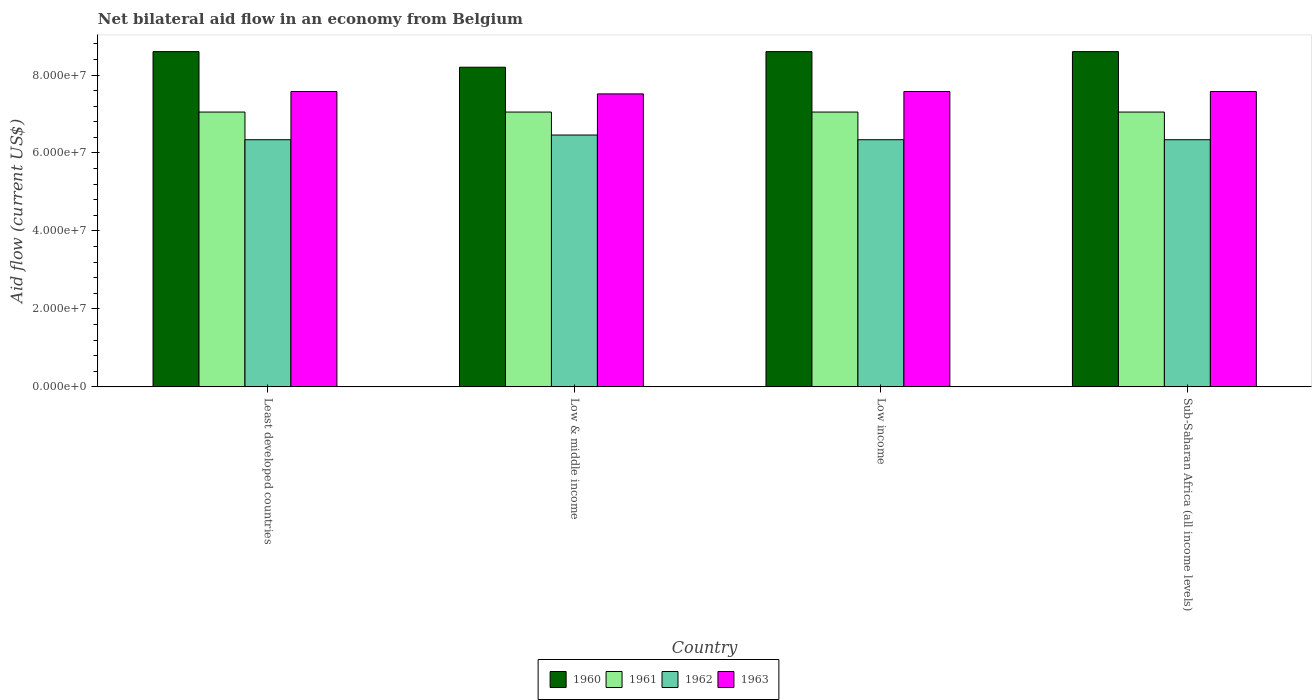How many different coloured bars are there?
Offer a terse response. 4. How many groups of bars are there?
Give a very brief answer. 4. Are the number of bars per tick equal to the number of legend labels?
Your answer should be compact. Yes. Are the number of bars on each tick of the X-axis equal?
Your answer should be very brief. Yes. How many bars are there on the 1st tick from the left?
Your answer should be very brief. 4. How many bars are there on the 4th tick from the right?
Your response must be concise. 4. What is the label of the 2nd group of bars from the left?
Provide a short and direct response. Low & middle income. What is the net bilateral aid flow in 1961 in Low income?
Ensure brevity in your answer.  7.05e+07. Across all countries, what is the maximum net bilateral aid flow in 1960?
Offer a terse response. 8.60e+07. Across all countries, what is the minimum net bilateral aid flow in 1961?
Offer a terse response. 7.05e+07. In which country was the net bilateral aid flow in 1960 minimum?
Provide a succinct answer. Low & middle income. What is the total net bilateral aid flow in 1960 in the graph?
Your response must be concise. 3.40e+08. What is the difference between the net bilateral aid flow in 1963 in Least developed countries and that in Sub-Saharan Africa (all income levels)?
Provide a succinct answer. 0. What is the difference between the net bilateral aid flow in 1961 in Low income and the net bilateral aid flow in 1960 in Least developed countries?
Make the answer very short. -1.55e+07. What is the average net bilateral aid flow in 1961 per country?
Provide a short and direct response. 7.05e+07. What is the difference between the net bilateral aid flow of/in 1961 and net bilateral aid flow of/in 1963 in Sub-Saharan Africa (all income levels)?
Provide a succinct answer. -5.27e+06. In how many countries, is the net bilateral aid flow in 1960 greater than 68000000 US$?
Give a very brief answer. 4. What is the ratio of the net bilateral aid flow in 1960 in Low & middle income to that in Low income?
Your response must be concise. 0.95. Is the net bilateral aid flow in 1960 in Least developed countries less than that in Low income?
Your response must be concise. No. What is the difference between the highest and the second highest net bilateral aid flow in 1962?
Ensure brevity in your answer.  1.21e+06. What is the difference between the highest and the lowest net bilateral aid flow in 1962?
Provide a succinct answer. 1.21e+06. Is the sum of the net bilateral aid flow in 1962 in Low income and Sub-Saharan Africa (all income levels) greater than the maximum net bilateral aid flow in 1961 across all countries?
Make the answer very short. Yes. Is it the case that in every country, the sum of the net bilateral aid flow in 1960 and net bilateral aid flow in 1962 is greater than the net bilateral aid flow in 1961?
Your answer should be compact. Yes. How many bars are there?
Give a very brief answer. 16. Are all the bars in the graph horizontal?
Your answer should be very brief. No. Where does the legend appear in the graph?
Ensure brevity in your answer.  Bottom center. How many legend labels are there?
Provide a short and direct response. 4. How are the legend labels stacked?
Provide a short and direct response. Horizontal. What is the title of the graph?
Keep it short and to the point. Net bilateral aid flow in an economy from Belgium. Does "2013" appear as one of the legend labels in the graph?
Your answer should be very brief. No. What is the Aid flow (current US$) of 1960 in Least developed countries?
Provide a short and direct response. 8.60e+07. What is the Aid flow (current US$) of 1961 in Least developed countries?
Your answer should be compact. 7.05e+07. What is the Aid flow (current US$) in 1962 in Least developed countries?
Keep it short and to the point. 6.34e+07. What is the Aid flow (current US$) of 1963 in Least developed countries?
Ensure brevity in your answer.  7.58e+07. What is the Aid flow (current US$) of 1960 in Low & middle income?
Give a very brief answer. 8.20e+07. What is the Aid flow (current US$) in 1961 in Low & middle income?
Keep it short and to the point. 7.05e+07. What is the Aid flow (current US$) in 1962 in Low & middle income?
Your answer should be compact. 6.46e+07. What is the Aid flow (current US$) in 1963 in Low & middle income?
Ensure brevity in your answer.  7.52e+07. What is the Aid flow (current US$) of 1960 in Low income?
Offer a terse response. 8.60e+07. What is the Aid flow (current US$) in 1961 in Low income?
Your answer should be very brief. 7.05e+07. What is the Aid flow (current US$) of 1962 in Low income?
Give a very brief answer. 6.34e+07. What is the Aid flow (current US$) of 1963 in Low income?
Your answer should be compact. 7.58e+07. What is the Aid flow (current US$) of 1960 in Sub-Saharan Africa (all income levels)?
Provide a short and direct response. 8.60e+07. What is the Aid flow (current US$) of 1961 in Sub-Saharan Africa (all income levels)?
Provide a succinct answer. 7.05e+07. What is the Aid flow (current US$) in 1962 in Sub-Saharan Africa (all income levels)?
Offer a very short reply. 6.34e+07. What is the Aid flow (current US$) in 1963 in Sub-Saharan Africa (all income levels)?
Give a very brief answer. 7.58e+07. Across all countries, what is the maximum Aid flow (current US$) in 1960?
Make the answer very short. 8.60e+07. Across all countries, what is the maximum Aid flow (current US$) in 1961?
Provide a short and direct response. 7.05e+07. Across all countries, what is the maximum Aid flow (current US$) in 1962?
Your response must be concise. 6.46e+07. Across all countries, what is the maximum Aid flow (current US$) in 1963?
Offer a very short reply. 7.58e+07. Across all countries, what is the minimum Aid flow (current US$) in 1960?
Keep it short and to the point. 8.20e+07. Across all countries, what is the minimum Aid flow (current US$) of 1961?
Keep it short and to the point. 7.05e+07. Across all countries, what is the minimum Aid flow (current US$) of 1962?
Offer a very short reply. 6.34e+07. Across all countries, what is the minimum Aid flow (current US$) in 1963?
Keep it short and to the point. 7.52e+07. What is the total Aid flow (current US$) in 1960 in the graph?
Ensure brevity in your answer.  3.40e+08. What is the total Aid flow (current US$) of 1961 in the graph?
Ensure brevity in your answer.  2.82e+08. What is the total Aid flow (current US$) in 1962 in the graph?
Keep it short and to the point. 2.55e+08. What is the total Aid flow (current US$) in 1963 in the graph?
Provide a succinct answer. 3.02e+08. What is the difference between the Aid flow (current US$) in 1960 in Least developed countries and that in Low & middle income?
Provide a short and direct response. 4.00e+06. What is the difference between the Aid flow (current US$) of 1961 in Least developed countries and that in Low & middle income?
Give a very brief answer. 0. What is the difference between the Aid flow (current US$) of 1962 in Least developed countries and that in Low & middle income?
Make the answer very short. -1.21e+06. What is the difference between the Aid flow (current US$) of 1963 in Least developed countries and that in Low & middle income?
Make the answer very short. 6.10e+05. What is the difference between the Aid flow (current US$) of 1960 in Least developed countries and that in Low income?
Ensure brevity in your answer.  0. What is the difference between the Aid flow (current US$) of 1961 in Least developed countries and that in Low income?
Provide a succinct answer. 0. What is the difference between the Aid flow (current US$) of 1961 in Least developed countries and that in Sub-Saharan Africa (all income levels)?
Keep it short and to the point. 0. What is the difference between the Aid flow (current US$) of 1962 in Least developed countries and that in Sub-Saharan Africa (all income levels)?
Your answer should be compact. 0. What is the difference between the Aid flow (current US$) in 1963 in Least developed countries and that in Sub-Saharan Africa (all income levels)?
Provide a succinct answer. 0. What is the difference between the Aid flow (current US$) of 1962 in Low & middle income and that in Low income?
Provide a short and direct response. 1.21e+06. What is the difference between the Aid flow (current US$) of 1963 in Low & middle income and that in Low income?
Your response must be concise. -6.10e+05. What is the difference between the Aid flow (current US$) in 1960 in Low & middle income and that in Sub-Saharan Africa (all income levels)?
Offer a very short reply. -4.00e+06. What is the difference between the Aid flow (current US$) in 1962 in Low & middle income and that in Sub-Saharan Africa (all income levels)?
Offer a very short reply. 1.21e+06. What is the difference between the Aid flow (current US$) in 1963 in Low & middle income and that in Sub-Saharan Africa (all income levels)?
Give a very brief answer. -6.10e+05. What is the difference between the Aid flow (current US$) of 1963 in Low income and that in Sub-Saharan Africa (all income levels)?
Make the answer very short. 0. What is the difference between the Aid flow (current US$) of 1960 in Least developed countries and the Aid flow (current US$) of 1961 in Low & middle income?
Provide a succinct answer. 1.55e+07. What is the difference between the Aid flow (current US$) of 1960 in Least developed countries and the Aid flow (current US$) of 1962 in Low & middle income?
Keep it short and to the point. 2.14e+07. What is the difference between the Aid flow (current US$) in 1960 in Least developed countries and the Aid flow (current US$) in 1963 in Low & middle income?
Your answer should be very brief. 1.08e+07. What is the difference between the Aid flow (current US$) of 1961 in Least developed countries and the Aid flow (current US$) of 1962 in Low & middle income?
Ensure brevity in your answer.  5.89e+06. What is the difference between the Aid flow (current US$) of 1961 in Least developed countries and the Aid flow (current US$) of 1963 in Low & middle income?
Your answer should be very brief. -4.66e+06. What is the difference between the Aid flow (current US$) of 1962 in Least developed countries and the Aid flow (current US$) of 1963 in Low & middle income?
Offer a terse response. -1.18e+07. What is the difference between the Aid flow (current US$) in 1960 in Least developed countries and the Aid flow (current US$) in 1961 in Low income?
Your response must be concise. 1.55e+07. What is the difference between the Aid flow (current US$) in 1960 in Least developed countries and the Aid flow (current US$) in 1962 in Low income?
Your answer should be very brief. 2.26e+07. What is the difference between the Aid flow (current US$) of 1960 in Least developed countries and the Aid flow (current US$) of 1963 in Low income?
Your response must be concise. 1.02e+07. What is the difference between the Aid flow (current US$) in 1961 in Least developed countries and the Aid flow (current US$) in 1962 in Low income?
Your answer should be compact. 7.10e+06. What is the difference between the Aid flow (current US$) of 1961 in Least developed countries and the Aid flow (current US$) of 1963 in Low income?
Make the answer very short. -5.27e+06. What is the difference between the Aid flow (current US$) in 1962 in Least developed countries and the Aid flow (current US$) in 1963 in Low income?
Ensure brevity in your answer.  -1.24e+07. What is the difference between the Aid flow (current US$) in 1960 in Least developed countries and the Aid flow (current US$) in 1961 in Sub-Saharan Africa (all income levels)?
Your response must be concise. 1.55e+07. What is the difference between the Aid flow (current US$) of 1960 in Least developed countries and the Aid flow (current US$) of 1962 in Sub-Saharan Africa (all income levels)?
Make the answer very short. 2.26e+07. What is the difference between the Aid flow (current US$) of 1960 in Least developed countries and the Aid flow (current US$) of 1963 in Sub-Saharan Africa (all income levels)?
Your answer should be very brief. 1.02e+07. What is the difference between the Aid flow (current US$) of 1961 in Least developed countries and the Aid flow (current US$) of 1962 in Sub-Saharan Africa (all income levels)?
Your answer should be compact. 7.10e+06. What is the difference between the Aid flow (current US$) of 1961 in Least developed countries and the Aid flow (current US$) of 1963 in Sub-Saharan Africa (all income levels)?
Provide a short and direct response. -5.27e+06. What is the difference between the Aid flow (current US$) in 1962 in Least developed countries and the Aid flow (current US$) in 1963 in Sub-Saharan Africa (all income levels)?
Make the answer very short. -1.24e+07. What is the difference between the Aid flow (current US$) in 1960 in Low & middle income and the Aid flow (current US$) in 1961 in Low income?
Your answer should be very brief. 1.15e+07. What is the difference between the Aid flow (current US$) of 1960 in Low & middle income and the Aid flow (current US$) of 1962 in Low income?
Your answer should be very brief. 1.86e+07. What is the difference between the Aid flow (current US$) of 1960 in Low & middle income and the Aid flow (current US$) of 1963 in Low income?
Your answer should be compact. 6.23e+06. What is the difference between the Aid flow (current US$) in 1961 in Low & middle income and the Aid flow (current US$) in 1962 in Low income?
Make the answer very short. 7.10e+06. What is the difference between the Aid flow (current US$) of 1961 in Low & middle income and the Aid flow (current US$) of 1963 in Low income?
Your answer should be very brief. -5.27e+06. What is the difference between the Aid flow (current US$) of 1962 in Low & middle income and the Aid flow (current US$) of 1963 in Low income?
Keep it short and to the point. -1.12e+07. What is the difference between the Aid flow (current US$) of 1960 in Low & middle income and the Aid flow (current US$) of 1961 in Sub-Saharan Africa (all income levels)?
Give a very brief answer. 1.15e+07. What is the difference between the Aid flow (current US$) in 1960 in Low & middle income and the Aid flow (current US$) in 1962 in Sub-Saharan Africa (all income levels)?
Keep it short and to the point. 1.86e+07. What is the difference between the Aid flow (current US$) in 1960 in Low & middle income and the Aid flow (current US$) in 1963 in Sub-Saharan Africa (all income levels)?
Give a very brief answer. 6.23e+06. What is the difference between the Aid flow (current US$) of 1961 in Low & middle income and the Aid flow (current US$) of 1962 in Sub-Saharan Africa (all income levels)?
Your answer should be very brief. 7.10e+06. What is the difference between the Aid flow (current US$) in 1961 in Low & middle income and the Aid flow (current US$) in 1963 in Sub-Saharan Africa (all income levels)?
Give a very brief answer. -5.27e+06. What is the difference between the Aid flow (current US$) of 1962 in Low & middle income and the Aid flow (current US$) of 1963 in Sub-Saharan Africa (all income levels)?
Keep it short and to the point. -1.12e+07. What is the difference between the Aid flow (current US$) of 1960 in Low income and the Aid flow (current US$) of 1961 in Sub-Saharan Africa (all income levels)?
Offer a very short reply. 1.55e+07. What is the difference between the Aid flow (current US$) in 1960 in Low income and the Aid flow (current US$) in 1962 in Sub-Saharan Africa (all income levels)?
Offer a terse response. 2.26e+07. What is the difference between the Aid flow (current US$) of 1960 in Low income and the Aid flow (current US$) of 1963 in Sub-Saharan Africa (all income levels)?
Give a very brief answer. 1.02e+07. What is the difference between the Aid flow (current US$) in 1961 in Low income and the Aid flow (current US$) in 1962 in Sub-Saharan Africa (all income levels)?
Your answer should be compact. 7.10e+06. What is the difference between the Aid flow (current US$) of 1961 in Low income and the Aid flow (current US$) of 1963 in Sub-Saharan Africa (all income levels)?
Offer a terse response. -5.27e+06. What is the difference between the Aid flow (current US$) of 1962 in Low income and the Aid flow (current US$) of 1963 in Sub-Saharan Africa (all income levels)?
Your answer should be compact. -1.24e+07. What is the average Aid flow (current US$) in 1960 per country?
Offer a very short reply. 8.50e+07. What is the average Aid flow (current US$) of 1961 per country?
Provide a succinct answer. 7.05e+07. What is the average Aid flow (current US$) in 1962 per country?
Ensure brevity in your answer.  6.37e+07. What is the average Aid flow (current US$) of 1963 per country?
Ensure brevity in your answer.  7.56e+07. What is the difference between the Aid flow (current US$) in 1960 and Aid flow (current US$) in 1961 in Least developed countries?
Your answer should be compact. 1.55e+07. What is the difference between the Aid flow (current US$) of 1960 and Aid flow (current US$) of 1962 in Least developed countries?
Keep it short and to the point. 2.26e+07. What is the difference between the Aid flow (current US$) in 1960 and Aid flow (current US$) in 1963 in Least developed countries?
Keep it short and to the point. 1.02e+07. What is the difference between the Aid flow (current US$) of 1961 and Aid flow (current US$) of 1962 in Least developed countries?
Provide a short and direct response. 7.10e+06. What is the difference between the Aid flow (current US$) in 1961 and Aid flow (current US$) in 1963 in Least developed countries?
Ensure brevity in your answer.  -5.27e+06. What is the difference between the Aid flow (current US$) in 1962 and Aid flow (current US$) in 1963 in Least developed countries?
Your answer should be compact. -1.24e+07. What is the difference between the Aid flow (current US$) in 1960 and Aid flow (current US$) in 1961 in Low & middle income?
Provide a short and direct response. 1.15e+07. What is the difference between the Aid flow (current US$) of 1960 and Aid flow (current US$) of 1962 in Low & middle income?
Provide a succinct answer. 1.74e+07. What is the difference between the Aid flow (current US$) in 1960 and Aid flow (current US$) in 1963 in Low & middle income?
Provide a succinct answer. 6.84e+06. What is the difference between the Aid flow (current US$) of 1961 and Aid flow (current US$) of 1962 in Low & middle income?
Offer a very short reply. 5.89e+06. What is the difference between the Aid flow (current US$) in 1961 and Aid flow (current US$) in 1963 in Low & middle income?
Ensure brevity in your answer.  -4.66e+06. What is the difference between the Aid flow (current US$) in 1962 and Aid flow (current US$) in 1963 in Low & middle income?
Offer a terse response. -1.06e+07. What is the difference between the Aid flow (current US$) of 1960 and Aid flow (current US$) of 1961 in Low income?
Ensure brevity in your answer.  1.55e+07. What is the difference between the Aid flow (current US$) in 1960 and Aid flow (current US$) in 1962 in Low income?
Your answer should be very brief. 2.26e+07. What is the difference between the Aid flow (current US$) of 1960 and Aid flow (current US$) of 1963 in Low income?
Offer a terse response. 1.02e+07. What is the difference between the Aid flow (current US$) in 1961 and Aid flow (current US$) in 1962 in Low income?
Your response must be concise. 7.10e+06. What is the difference between the Aid flow (current US$) in 1961 and Aid flow (current US$) in 1963 in Low income?
Your response must be concise. -5.27e+06. What is the difference between the Aid flow (current US$) in 1962 and Aid flow (current US$) in 1963 in Low income?
Offer a terse response. -1.24e+07. What is the difference between the Aid flow (current US$) in 1960 and Aid flow (current US$) in 1961 in Sub-Saharan Africa (all income levels)?
Offer a terse response. 1.55e+07. What is the difference between the Aid flow (current US$) of 1960 and Aid flow (current US$) of 1962 in Sub-Saharan Africa (all income levels)?
Your answer should be compact. 2.26e+07. What is the difference between the Aid flow (current US$) of 1960 and Aid flow (current US$) of 1963 in Sub-Saharan Africa (all income levels)?
Offer a terse response. 1.02e+07. What is the difference between the Aid flow (current US$) of 1961 and Aid flow (current US$) of 1962 in Sub-Saharan Africa (all income levels)?
Make the answer very short. 7.10e+06. What is the difference between the Aid flow (current US$) in 1961 and Aid flow (current US$) in 1963 in Sub-Saharan Africa (all income levels)?
Your answer should be compact. -5.27e+06. What is the difference between the Aid flow (current US$) in 1962 and Aid flow (current US$) in 1963 in Sub-Saharan Africa (all income levels)?
Provide a short and direct response. -1.24e+07. What is the ratio of the Aid flow (current US$) of 1960 in Least developed countries to that in Low & middle income?
Your answer should be compact. 1.05. What is the ratio of the Aid flow (current US$) in 1962 in Least developed countries to that in Low & middle income?
Your answer should be very brief. 0.98. What is the ratio of the Aid flow (current US$) of 1963 in Least developed countries to that in Low & middle income?
Ensure brevity in your answer.  1.01. What is the ratio of the Aid flow (current US$) in 1960 in Least developed countries to that in Low income?
Ensure brevity in your answer.  1. What is the ratio of the Aid flow (current US$) in 1961 in Least developed countries to that in Low income?
Your answer should be compact. 1. What is the ratio of the Aid flow (current US$) in 1962 in Least developed countries to that in Low income?
Your answer should be very brief. 1. What is the ratio of the Aid flow (current US$) in 1963 in Least developed countries to that in Low income?
Provide a short and direct response. 1. What is the ratio of the Aid flow (current US$) in 1963 in Least developed countries to that in Sub-Saharan Africa (all income levels)?
Provide a succinct answer. 1. What is the ratio of the Aid flow (current US$) in 1960 in Low & middle income to that in Low income?
Provide a short and direct response. 0.95. What is the ratio of the Aid flow (current US$) of 1961 in Low & middle income to that in Low income?
Your response must be concise. 1. What is the ratio of the Aid flow (current US$) of 1962 in Low & middle income to that in Low income?
Offer a terse response. 1.02. What is the ratio of the Aid flow (current US$) in 1960 in Low & middle income to that in Sub-Saharan Africa (all income levels)?
Your answer should be compact. 0.95. What is the ratio of the Aid flow (current US$) in 1961 in Low & middle income to that in Sub-Saharan Africa (all income levels)?
Keep it short and to the point. 1. What is the ratio of the Aid flow (current US$) in 1962 in Low & middle income to that in Sub-Saharan Africa (all income levels)?
Provide a succinct answer. 1.02. What is the ratio of the Aid flow (current US$) of 1962 in Low income to that in Sub-Saharan Africa (all income levels)?
Provide a succinct answer. 1. What is the ratio of the Aid flow (current US$) in 1963 in Low income to that in Sub-Saharan Africa (all income levels)?
Provide a short and direct response. 1. What is the difference between the highest and the second highest Aid flow (current US$) of 1962?
Ensure brevity in your answer.  1.21e+06. What is the difference between the highest and the second highest Aid flow (current US$) of 1963?
Your answer should be very brief. 0. What is the difference between the highest and the lowest Aid flow (current US$) of 1960?
Give a very brief answer. 4.00e+06. What is the difference between the highest and the lowest Aid flow (current US$) in 1961?
Give a very brief answer. 0. What is the difference between the highest and the lowest Aid flow (current US$) in 1962?
Ensure brevity in your answer.  1.21e+06. What is the difference between the highest and the lowest Aid flow (current US$) in 1963?
Offer a very short reply. 6.10e+05. 